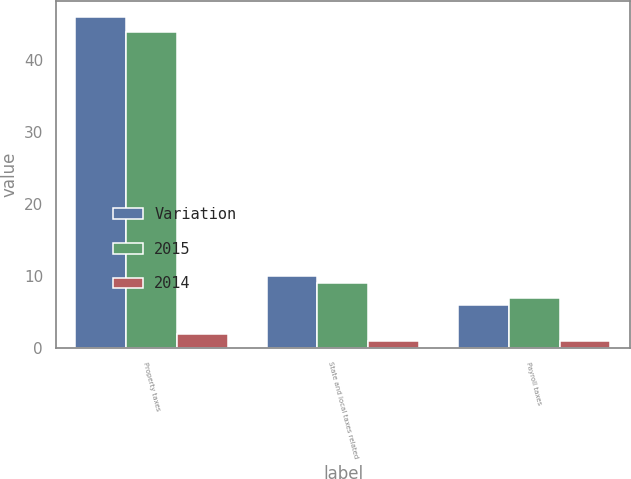Convert chart. <chart><loc_0><loc_0><loc_500><loc_500><stacked_bar_chart><ecel><fcel>Property taxes<fcel>State and local taxes related<fcel>Payroll taxes<nl><fcel>Variation<fcel>46<fcel>10<fcel>6<nl><fcel>2015<fcel>44<fcel>9<fcel>7<nl><fcel>2014<fcel>2<fcel>1<fcel>1<nl></chart> 